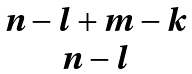Convert formula to latex. <formula><loc_0><loc_0><loc_500><loc_500>\begin{matrix} n - l + m - k \\ n - l \end{matrix}</formula> 